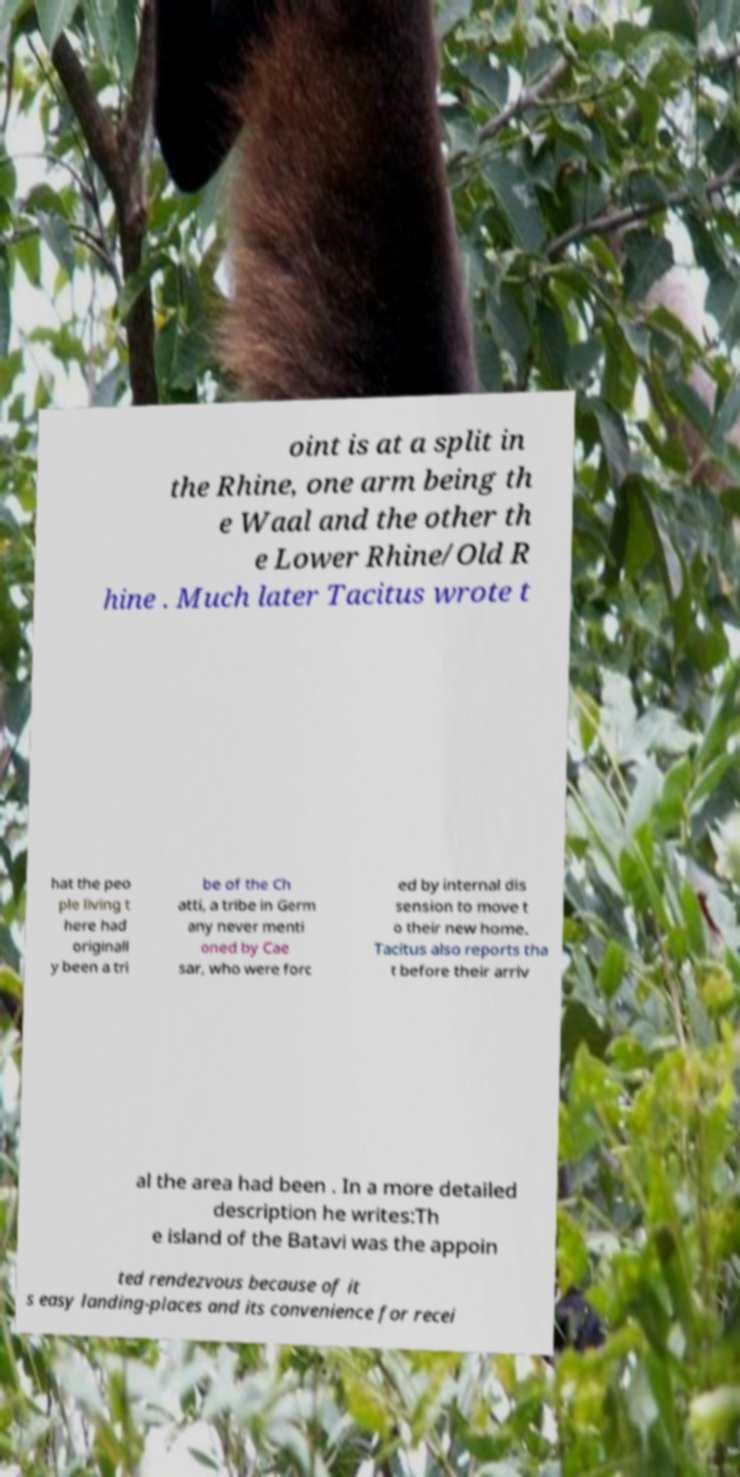There's text embedded in this image that I need extracted. Can you transcribe it verbatim? oint is at a split in the Rhine, one arm being th e Waal and the other th e Lower Rhine/Old R hine . Much later Tacitus wrote t hat the peo ple living t here had originall y been a tri be of the Ch atti, a tribe in Germ any never menti oned by Cae sar, who were forc ed by internal dis sension to move t o their new home. Tacitus also reports tha t before their arriv al the area had been . In a more detailed description he writes:Th e island of the Batavi was the appoin ted rendezvous because of it s easy landing-places and its convenience for recei 